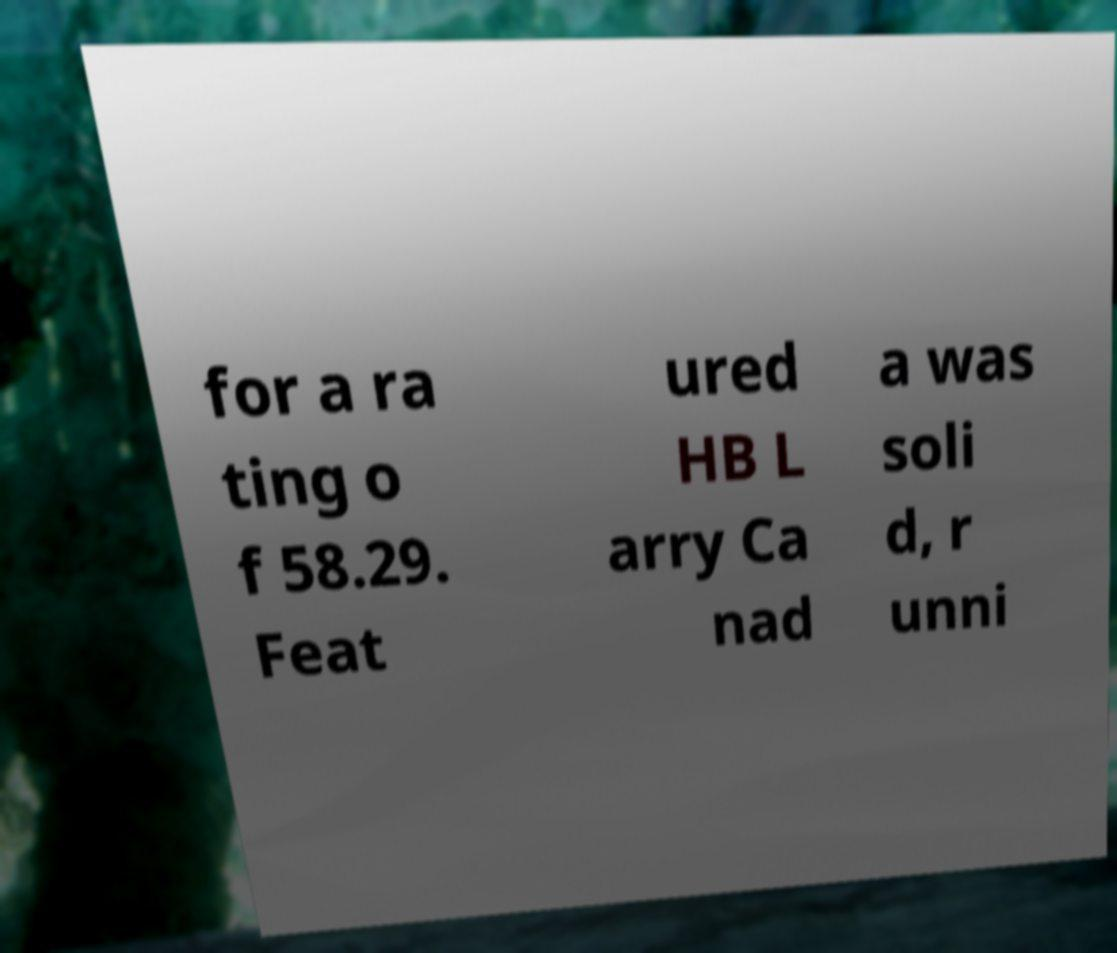For documentation purposes, I need the text within this image transcribed. Could you provide that? for a ra ting o f 58.29. Feat ured HB L arry Ca nad a was soli d, r unni 